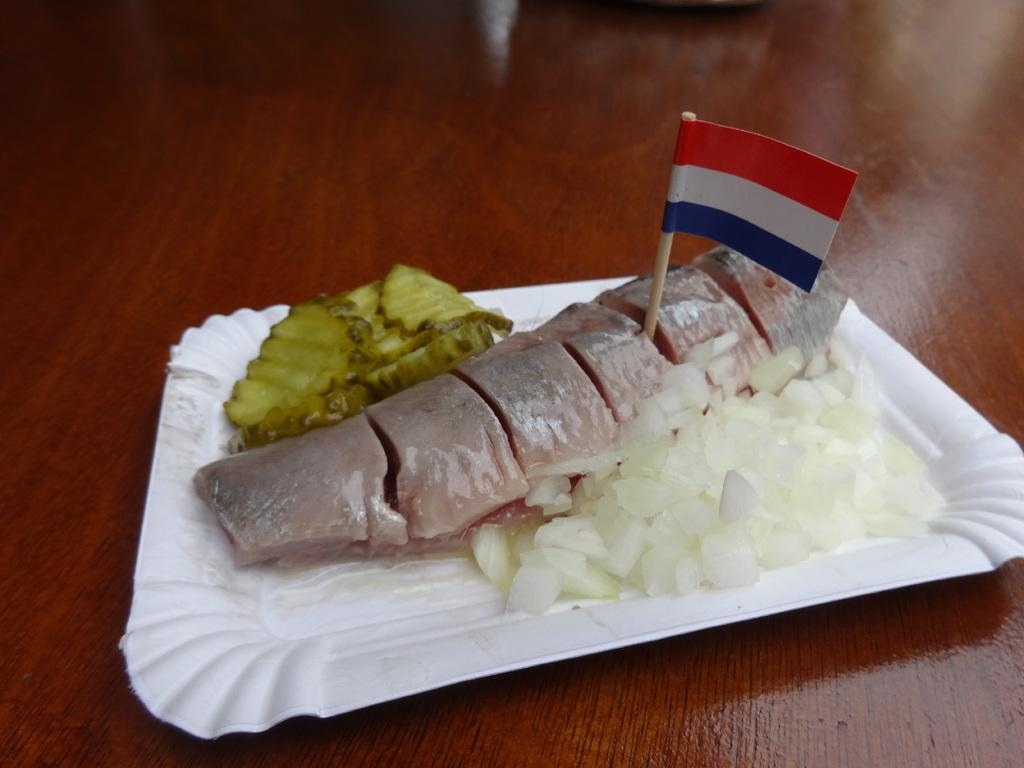What is on the plate that is visible in the image? There is food on a plate in the image. What other object can be seen in the image besides the plate? There is a flag in the image. On what type of surface is the plate placed? The plate is on a wooden surface. How is the wooden surface depicted in the image? The wooden surface appears to be truncated in the image. Can you tell me how many ladybugs are crawling on the flag in the image? There are no ladybugs present in the image; the flag is the only object mentioned in the facts. 